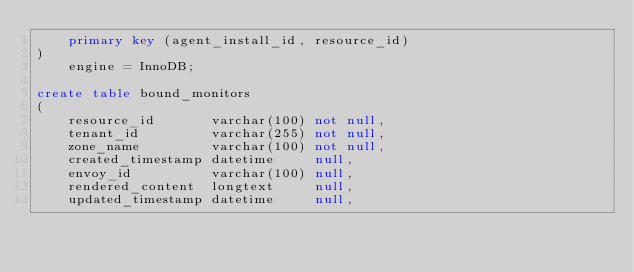<code> <loc_0><loc_0><loc_500><loc_500><_SQL_>    primary key (agent_install_id, resource_id)
)
    engine = InnoDB;

create table bound_monitors
(
    resource_id       varchar(100) not null,
    tenant_id         varchar(255) not null,
    zone_name         varchar(100) not null,
    created_timestamp datetime     null,
    envoy_id          varchar(100) null,
    rendered_content  longtext     null,
    updated_timestamp datetime     null,</code> 